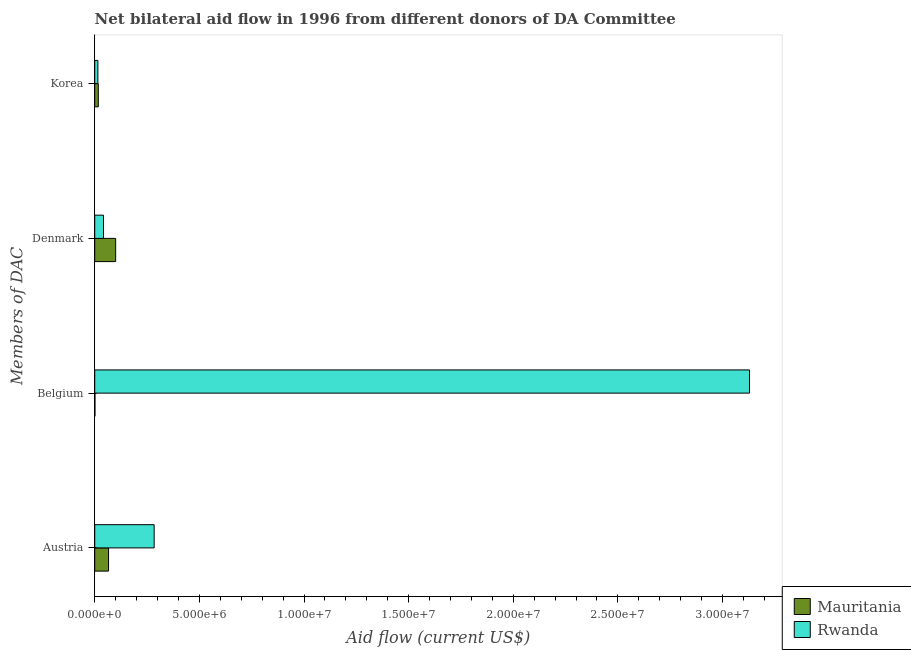How many different coloured bars are there?
Give a very brief answer. 2. How many bars are there on the 3rd tick from the bottom?
Your answer should be compact. 2. What is the amount of aid given by korea in Rwanda?
Offer a terse response. 1.50e+05. Across all countries, what is the maximum amount of aid given by austria?
Ensure brevity in your answer.  2.84e+06. Across all countries, what is the minimum amount of aid given by austria?
Ensure brevity in your answer.  6.60e+05. In which country was the amount of aid given by austria maximum?
Your response must be concise. Rwanda. In which country was the amount of aid given by denmark minimum?
Keep it short and to the point. Rwanda. What is the total amount of aid given by belgium in the graph?
Provide a short and direct response. 3.13e+07. What is the difference between the amount of aid given by austria in Mauritania and that in Rwanda?
Make the answer very short. -2.18e+06. What is the difference between the amount of aid given by austria in Rwanda and the amount of aid given by korea in Mauritania?
Provide a succinct answer. 2.67e+06. What is the average amount of aid given by austria per country?
Provide a short and direct response. 1.75e+06. What is the difference between the amount of aid given by belgium and amount of aid given by austria in Mauritania?
Give a very brief answer. -6.50e+05. In how many countries, is the amount of aid given by denmark greater than 23000000 US$?
Make the answer very short. 0. What is the ratio of the amount of aid given by belgium in Rwanda to that in Mauritania?
Provide a succinct answer. 3129. What is the difference between the highest and the second highest amount of aid given by belgium?
Keep it short and to the point. 3.13e+07. What is the difference between the highest and the lowest amount of aid given by korea?
Ensure brevity in your answer.  2.00e+04. What does the 2nd bar from the top in Belgium represents?
Offer a very short reply. Mauritania. What does the 1st bar from the bottom in Korea represents?
Provide a short and direct response. Mauritania. How many bars are there?
Provide a succinct answer. 8. How many countries are there in the graph?
Ensure brevity in your answer.  2. What is the difference between two consecutive major ticks on the X-axis?
Your answer should be very brief. 5.00e+06. Are the values on the major ticks of X-axis written in scientific E-notation?
Your answer should be compact. Yes. Does the graph contain any zero values?
Your answer should be very brief. No. Where does the legend appear in the graph?
Give a very brief answer. Bottom right. How many legend labels are there?
Offer a very short reply. 2. What is the title of the graph?
Ensure brevity in your answer.  Net bilateral aid flow in 1996 from different donors of DA Committee. What is the label or title of the X-axis?
Offer a terse response. Aid flow (current US$). What is the label or title of the Y-axis?
Provide a short and direct response. Members of DAC. What is the Aid flow (current US$) of Rwanda in Austria?
Make the answer very short. 2.84e+06. What is the Aid flow (current US$) in Mauritania in Belgium?
Provide a succinct answer. 10000. What is the Aid flow (current US$) of Rwanda in Belgium?
Keep it short and to the point. 3.13e+07. What is the Aid flow (current US$) of Mauritania in Korea?
Ensure brevity in your answer.  1.70e+05. What is the Aid flow (current US$) of Rwanda in Korea?
Make the answer very short. 1.50e+05. Across all Members of DAC, what is the maximum Aid flow (current US$) of Rwanda?
Offer a very short reply. 3.13e+07. Across all Members of DAC, what is the minimum Aid flow (current US$) of Mauritania?
Keep it short and to the point. 10000. What is the total Aid flow (current US$) in Mauritania in the graph?
Your answer should be very brief. 1.84e+06. What is the total Aid flow (current US$) in Rwanda in the graph?
Keep it short and to the point. 3.47e+07. What is the difference between the Aid flow (current US$) in Mauritania in Austria and that in Belgium?
Your answer should be very brief. 6.50e+05. What is the difference between the Aid flow (current US$) of Rwanda in Austria and that in Belgium?
Keep it short and to the point. -2.84e+07. What is the difference between the Aid flow (current US$) of Mauritania in Austria and that in Denmark?
Give a very brief answer. -3.40e+05. What is the difference between the Aid flow (current US$) in Rwanda in Austria and that in Denmark?
Offer a very short reply. 2.42e+06. What is the difference between the Aid flow (current US$) in Mauritania in Austria and that in Korea?
Provide a succinct answer. 4.90e+05. What is the difference between the Aid flow (current US$) in Rwanda in Austria and that in Korea?
Provide a short and direct response. 2.69e+06. What is the difference between the Aid flow (current US$) in Mauritania in Belgium and that in Denmark?
Give a very brief answer. -9.90e+05. What is the difference between the Aid flow (current US$) of Rwanda in Belgium and that in Denmark?
Your response must be concise. 3.09e+07. What is the difference between the Aid flow (current US$) of Mauritania in Belgium and that in Korea?
Keep it short and to the point. -1.60e+05. What is the difference between the Aid flow (current US$) of Rwanda in Belgium and that in Korea?
Your answer should be very brief. 3.11e+07. What is the difference between the Aid flow (current US$) in Mauritania in Denmark and that in Korea?
Keep it short and to the point. 8.30e+05. What is the difference between the Aid flow (current US$) of Mauritania in Austria and the Aid flow (current US$) of Rwanda in Belgium?
Provide a short and direct response. -3.06e+07. What is the difference between the Aid flow (current US$) of Mauritania in Austria and the Aid flow (current US$) of Rwanda in Korea?
Offer a terse response. 5.10e+05. What is the difference between the Aid flow (current US$) in Mauritania in Belgium and the Aid flow (current US$) in Rwanda in Denmark?
Keep it short and to the point. -4.10e+05. What is the difference between the Aid flow (current US$) of Mauritania in Denmark and the Aid flow (current US$) of Rwanda in Korea?
Offer a very short reply. 8.50e+05. What is the average Aid flow (current US$) of Mauritania per Members of DAC?
Offer a very short reply. 4.60e+05. What is the average Aid flow (current US$) in Rwanda per Members of DAC?
Your answer should be compact. 8.68e+06. What is the difference between the Aid flow (current US$) of Mauritania and Aid flow (current US$) of Rwanda in Austria?
Offer a terse response. -2.18e+06. What is the difference between the Aid flow (current US$) of Mauritania and Aid flow (current US$) of Rwanda in Belgium?
Make the answer very short. -3.13e+07. What is the difference between the Aid flow (current US$) of Mauritania and Aid flow (current US$) of Rwanda in Denmark?
Keep it short and to the point. 5.80e+05. What is the ratio of the Aid flow (current US$) in Rwanda in Austria to that in Belgium?
Your answer should be compact. 0.09. What is the ratio of the Aid flow (current US$) of Mauritania in Austria to that in Denmark?
Your answer should be compact. 0.66. What is the ratio of the Aid flow (current US$) of Rwanda in Austria to that in Denmark?
Offer a terse response. 6.76. What is the ratio of the Aid flow (current US$) of Mauritania in Austria to that in Korea?
Make the answer very short. 3.88. What is the ratio of the Aid flow (current US$) in Rwanda in Austria to that in Korea?
Your response must be concise. 18.93. What is the ratio of the Aid flow (current US$) in Mauritania in Belgium to that in Denmark?
Provide a succinct answer. 0.01. What is the ratio of the Aid flow (current US$) in Rwanda in Belgium to that in Denmark?
Your answer should be very brief. 74.5. What is the ratio of the Aid flow (current US$) of Mauritania in Belgium to that in Korea?
Provide a succinct answer. 0.06. What is the ratio of the Aid flow (current US$) of Rwanda in Belgium to that in Korea?
Give a very brief answer. 208.6. What is the ratio of the Aid flow (current US$) in Mauritania in Denmark to that in Korea?
Ensure brevity in your answer.  5.88. What is the difference between the highest and the second highest Aid flow (current US$) in Mauritania?
Provide a short and direct response. 3.40e+05. What is the difference between the highest and the second highest Aid flow (current US$) of Rwanda?
Offer a very short reply. 2.84e+07. What is the difference between the highest and the lowest Aid flow (current US$) of Mauritania?
Your answer should be very brief. 9.90e+05. What is the difference between the highest and the lowest Aid flow (current US$) of Rwanda?
Give a very brief answer. 3.11e+07. 